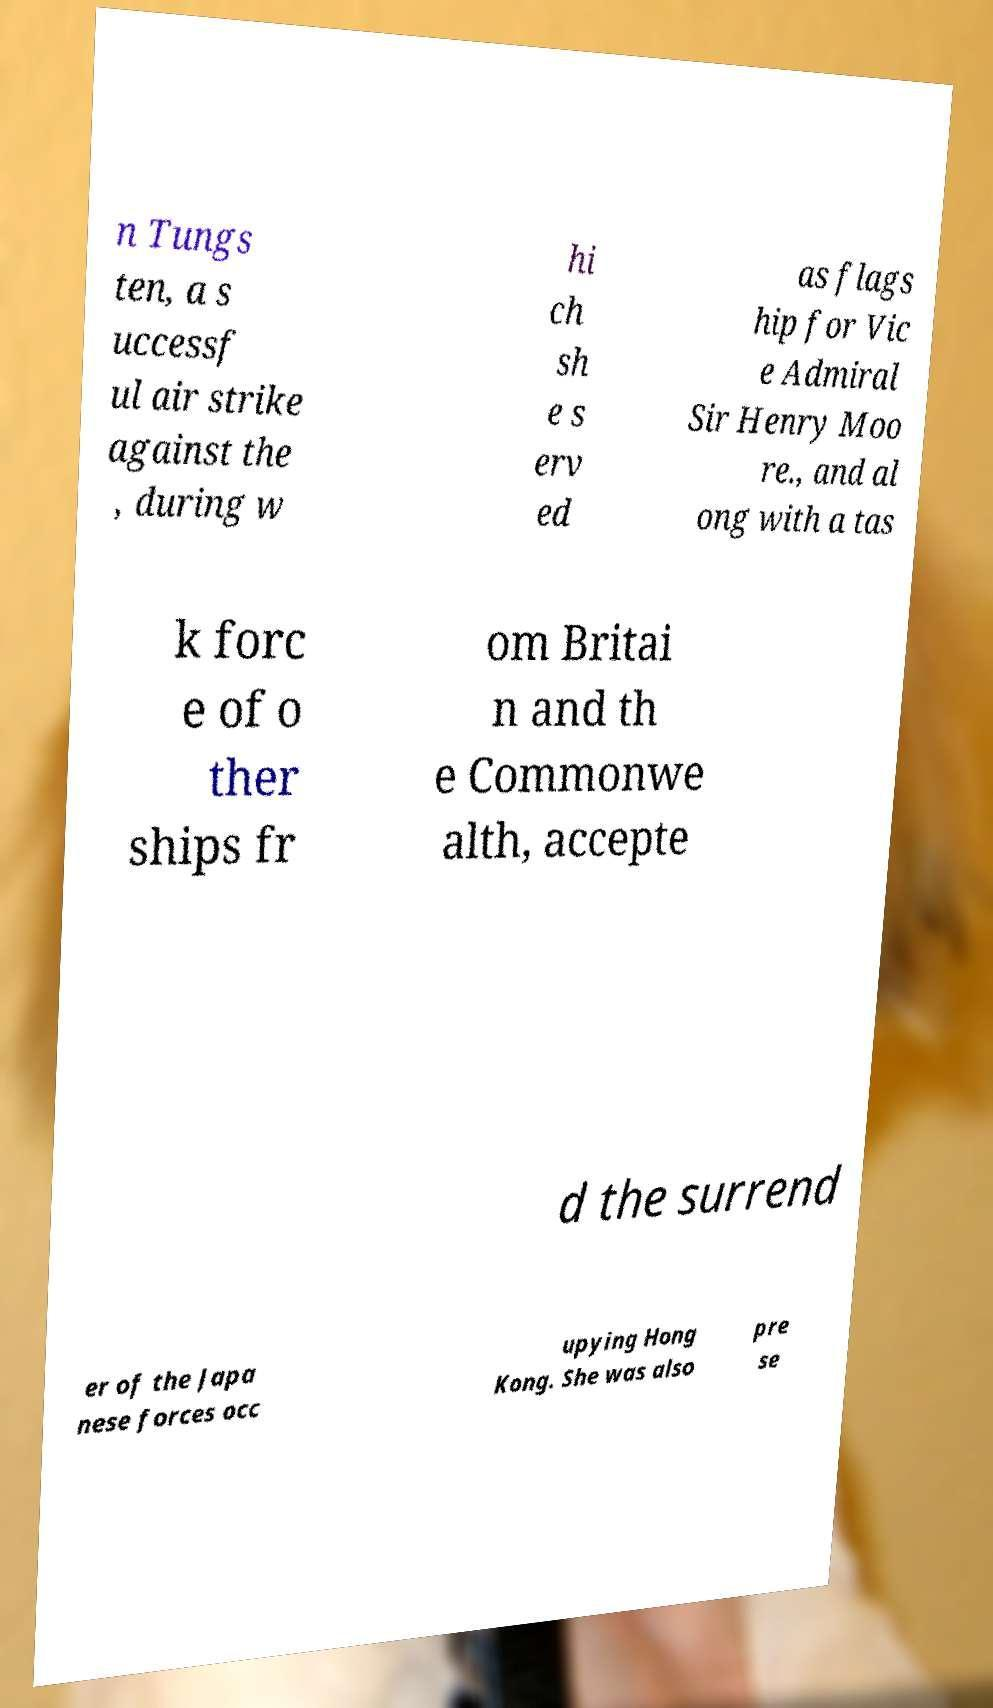Please identify and transcribe the text found in this image. n Tungs ten, a s uccessf ul air strike against the , during w hi ch sh e s erv ed as flags hip for Vic e Admiral Sir Henry Moo re., and al ong with a tas k forc e of o ther ships fr om Britai n and th e Commonwe alth, accepte d the surrend er of the Japa nese forces occ upying Hong Kong. She was also pre se 